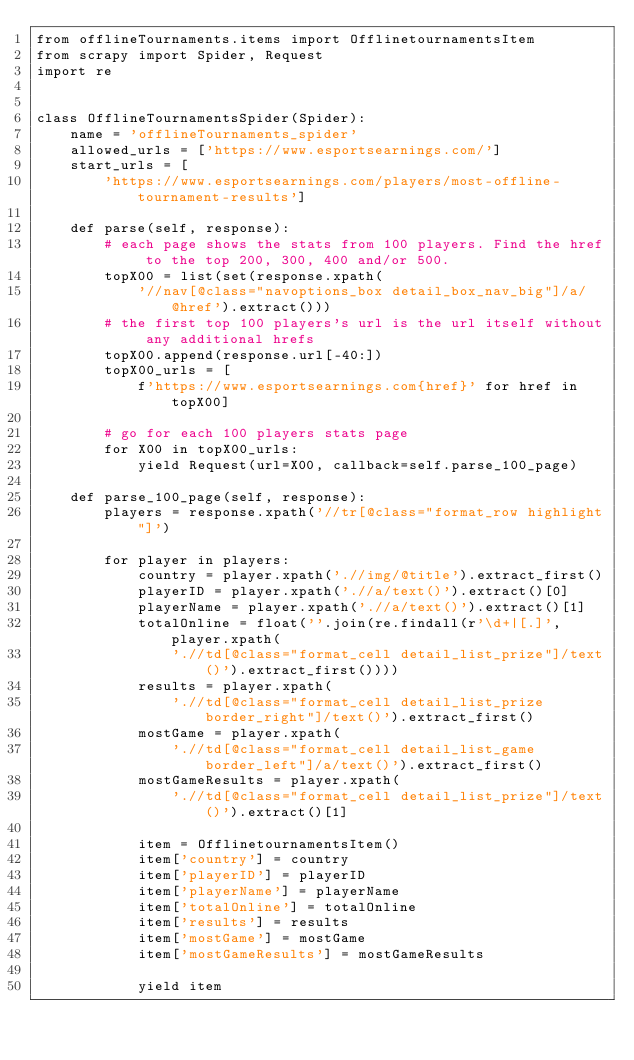<code> <loc_0><loc_0><loc_500><loc_500><_Python_>from offlineTournaments.items import OfflinetournamentsItem
from scrapy import Spider, Request
import re


class OfflineTournamentsSpider(Spider):
    name = 'offlineTournaments_spider'
    allowed_urls = ['https://www.esportsearnings.com/']
    start_urls = [
        'https://www.esportsearnings.com/players/most-offline-tournament-results']

    def parse(self, response):
        # each page shows the stats from 100 players. Find the href to the top 200, 300, 400 and/or 500.
        topX00 = list(set(response.xpath(
            '//nav[@class="navoptions_box detail_box_nav_big"]/a/@href').extract()))
        # the first top 100 players's url is the url itself without any additional hrefs
        topX00.append(response.url[-40:])
        topX00_urls = [
            f'https://www.esportsearnings.com{href}' for href in topX00]

        # go for each 100 players stats page
        for X00 in topX00_urls:
            yield Request(url=X00, callback=self.parse_100_page)

    def parse_100_page(self, response):
        players = response.xpath('//tr[@class="format_row highlight"]')

        for player in players:
            country = player.xpath('.//img/@title').extract_first()
            playerID = player.xpath('.//a/text()').extract()[0]
            playerName = player.xpath('.//a/text()').extract()[1]
            totalOnline = float(''.join(re.findall(r'\d+|[.]', player.xpath(
                './/td[@class="format_cell detail_list_prize"]/text()').extract_first())))
            results = player.xpath(
                './/td[@class="format_cell detail_list_prize border_right"]/text()').extract_first()
            mostGame = player.xpath(
                './/td[@class="format_cell detail_list_game border_left"]/a/text()').extract_first()
            mostGameResults = player.xpath(
                './/td[@class="format_cell detail_list_prize"]/text()').extract()[1]

            item = OfflinetournamentsItem()
            item['country'] = country
            item['playerID'] = playerID
            item['playerName'] = playerName
            item['totalOnline'] = totalOnline
            item['results'] = results
            item['mostGame'] = mostGame
            item['mostGameResults'] = mostGameResults

            yield item
</code> 